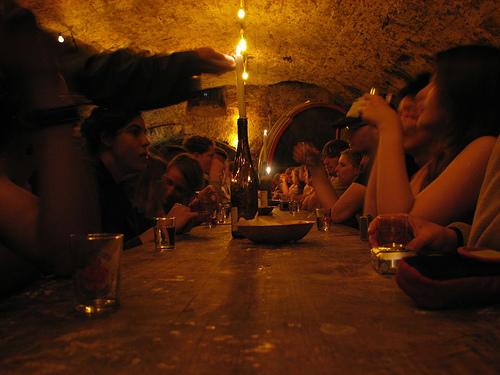What are the things that are lit up?
Answer briefly. Candles. Are the candles lit?
Short answer required. Yes. Are the people drinking?
Keep it brief. Yes. What event do you think is going on in the scene?
Write a very short answer. Dinner. 